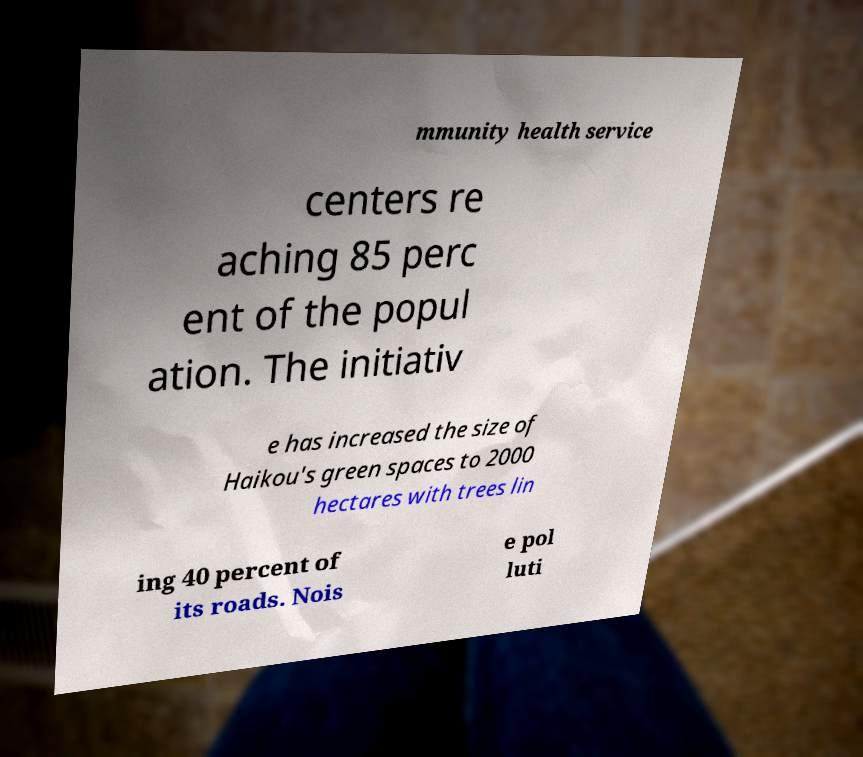I need the written content from this picture converted into text. Can you do that? mmunity health service centers re aching 85 perc ent of the popul ation. The initiativ e has increased the size of Haikou's green spaces to 2000 hectares with trees lin ing 40 percent of its roads. Nois e pol luti 